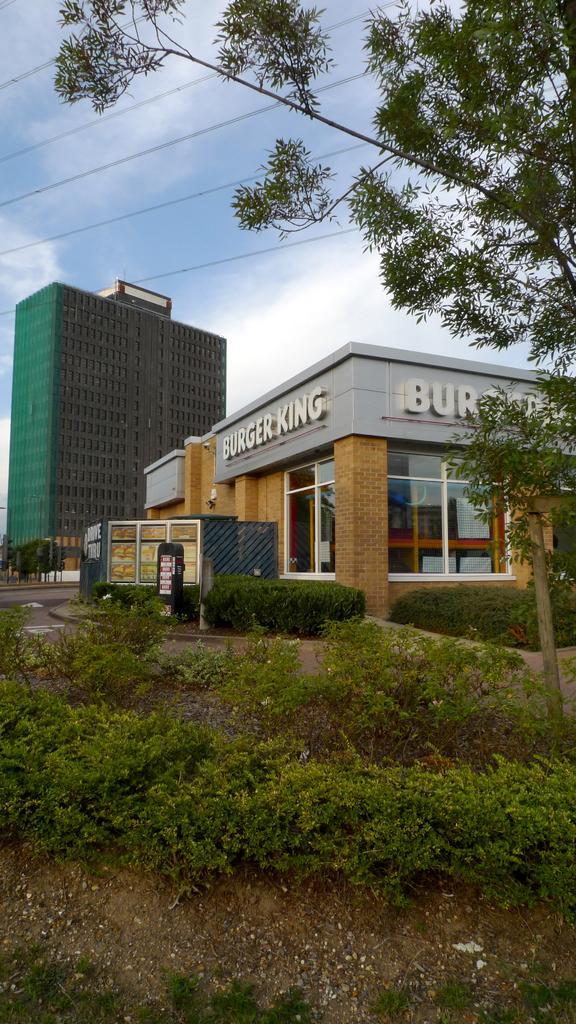Can you describe this image briefly? In this picture we can see plants, buildings, road, trees, wires and in the background we can see the sky with clouds. 